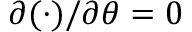<formula> <loc_0><loc_0><loc_500><loc_500>{ \partial ( \cdot ) } / { \partial \theta } = 0</formula> 